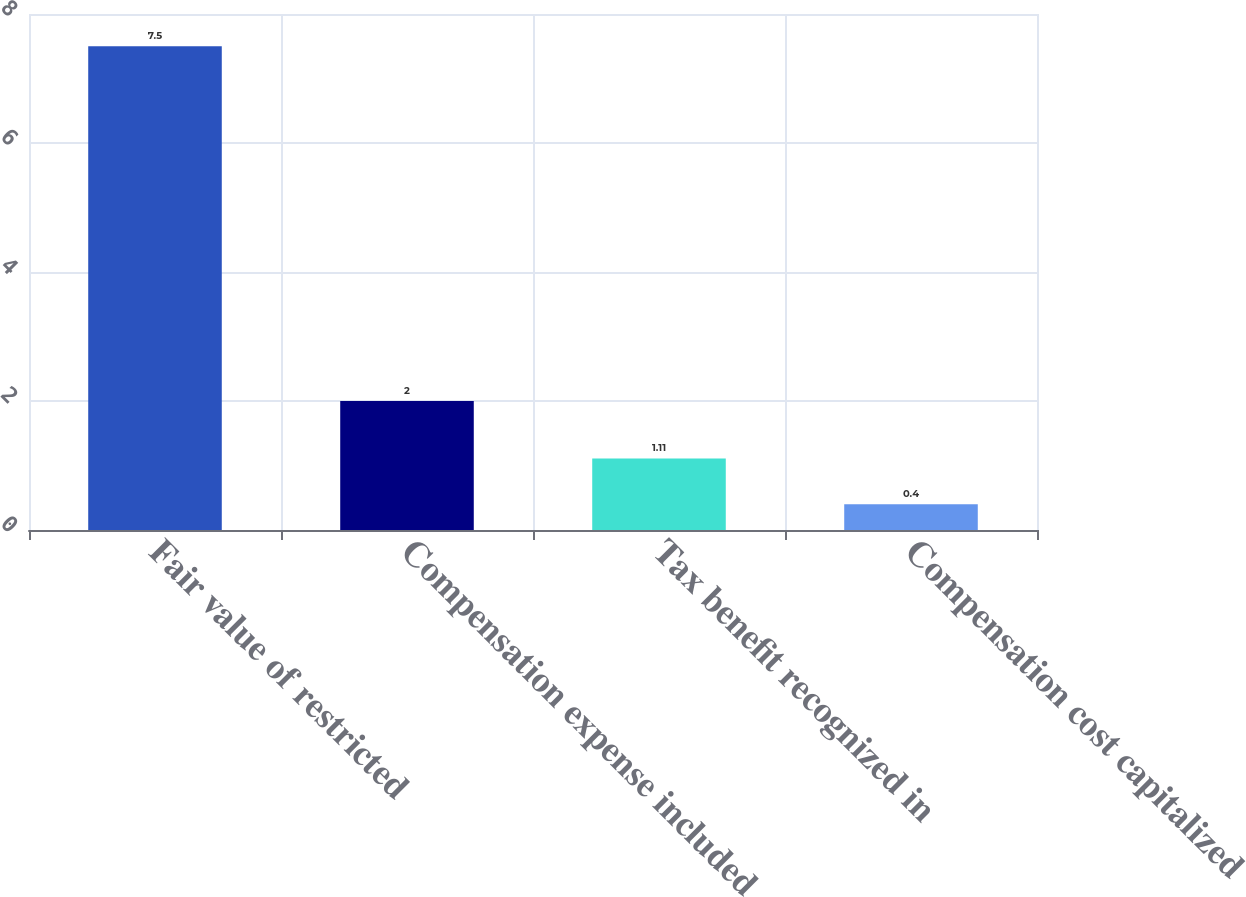Convert chart to OTSL. <chart><loc_0><loc_0><loc_500><loc_500><bar_chart><fcel>Fair value of restricted<fcel>Compensation expense included<fcel>Tax benefit recognized in<fcel>Compensation cost capitalized<nl><fcel>7.5<fcel>2<fcel>1.11<fcel>0.4<nl></chart> 